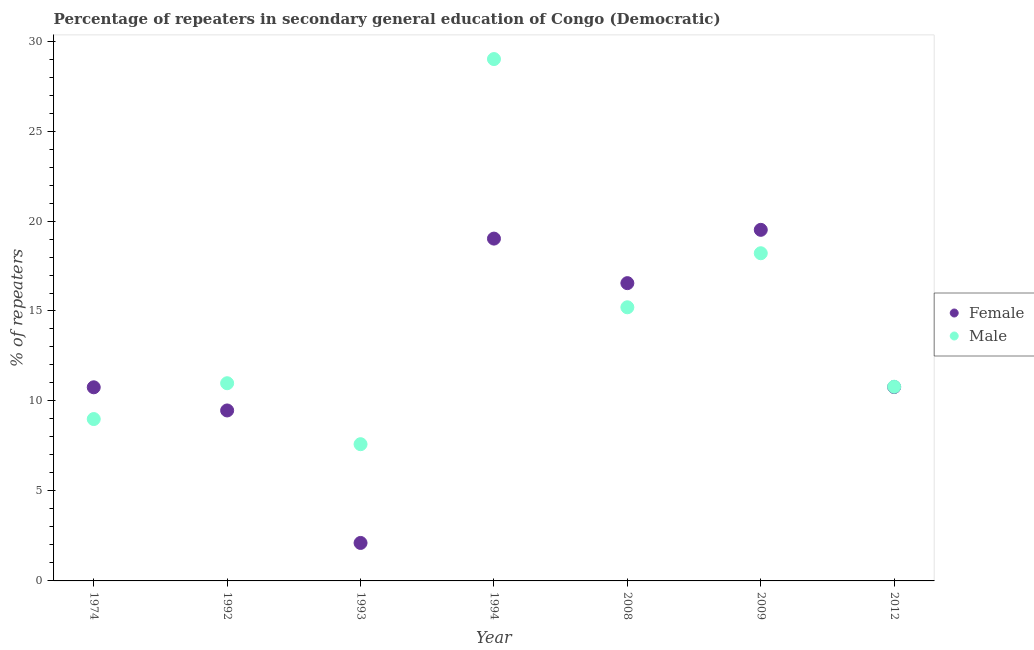What is the percentage of male repeaters in 1994?
Make the answer very short. 29. Across all years, what is the maximum percentage of female repeaters?
Give a very brief answer. 19.51. Across all years, what is the minimum percentage of male repeaters?
Provide a succinct answer. 7.6. In which year was the percentage of female repeaters minimum?
Offer a very short reply. 1993. What is the total percentage of female repeaters in the graph?
Offer a terse response. 88.2. What is the difference between the percentage of male repeaters in 1974 and that in 2008?
Provide a succinct answer. -6.21. What is the difference between the percentage of male repeaters in 1994 and the percentage of female repeaters in 1992?
Provide a short and direct response. 19.53. What is the average percentage of female repeaters per year?
Your response must be concise. 12.6. In the year 1974, what is the difference between the percentage of female repeaters and percentage of male repeaters?
Ensure brevity in your answer.  1.77. What is the ratio of the percentage of male repeaters in 1974 to that in 1992?
Give a very brief answer. 0.82. Is the percentage of female repeaters in 1974 less than that in 1992?
Offer a very short reply. No. What is the difference between the highest and the second highest percentage of male repeaters?
Give a very brief answer. 10.79. What is the difference between the highest and the lowest percentage of male repeaters?
Keep it short and to the point. 21.4. Is the sum of the percentage of female repeaters in 2009 and 2012 greater than the maximum percentage of male repeaters across all years?
Your answer should be compact. Yes. Does the percentage of male repeaters monotonically increase over the years?
Your answer should be very brief. No. Is the percentage of female repeaters strictly greater than the percentage of male repeaters over the years?
Ensure brevity in your answer.  No. Is the percentage of male repeaters strictly less than the percentage of female repeaters over the years?
Your answer should be very brief. No. How many years are there in the graph?
Your answer should be compact. 7. What is the difference between two consecutive major ticks on the Y-axis?
Your answer should be very brief. 5. Where does the legend appear in the graph?
Keep it short and to the point. Center right. What is the title of the graph?
Keep it short and to the point. Percentage of repeaters in secondary general education of Congo (Democratic). Does "Primary completion rate" appear as one of the legend labels in the graph?
Make the answer very short. No. What is the label or title of the Y-axis?
Provide a succinct answer. % of repeaters. What is the % of repeaters of Female in 1974?
Your answer should be compact. 10.76. What is the % of repeaters of Male in 1974?
Make the answer very short. 8.99. What is the % of repeaters of Female in 1992?
Ensure brevity in your answer.  9.47. What is the % of repeaters in Male in 1992?
Keep it short and to the point. 10.99. What is the % of repeaters in Female in 1993?
Your answer should be very brief. 2.11. What is the % of repeaters in Male in 1993?
Keep it short and to the point. 7.6. What is the % of repeaters of Female in 1994?
Offer a very short reply. 19.02. What is the % of repeaters in Male in 1994?
Keep it short and to the point. 29. What is the % of repeaters of Female in 2008?
Keep it short and to the point. 16.55. What is the % of repeaters in Male in 2008?
Offer a terse response. 15.21. What is the % of repeaters in Female in 2009?
Give a very brief answer. 19.51. What is the % of repeaters in Male in 2009?
Give a very brief answer. 18.21. What is the % of repeaters in Female in 2012?
Your answer should be very brief. 10.77. What is the % of repeaters of Male in 2012?
Provide a short and direct response. 10.79. Across all years, what is the maximum % of repeaters of Female?
Your response must be concise. 19.51. Across all years, what is the maximum % of repeaters in Male?
Provide a succinct answer. 29. Across all years, what is the minimum % of repeaters in Female?
Keep it short and to the point. 2.11. Across all years, what is the minimum % of repeaters of Male?
Your response must be concise. 7.6. What is the total % of repeaters in Female in the graph?
Offer a terse response. 88.2. What is the total % of repeaters in Male in the graph?
Your response must be concise. 100.79. What is the difference between the % of repeaters in Female in 1974 and that in 1992?
Your answer should be compact. 1.29. What is the difference between the % of repeaters of Male in 1974 and that in 1992?
Your answer should be very brief. -1.99. What is the difference between the % of repeaters of Female in 1974 and that in 1993?
Provide a succinct answer. 8.65. What is the difference between the % of repeaters of Male in 1974 and that in 1993?
Your answer should be very brief. 1.4. What is the difference between the % of repeaters of Female in 1974 and that in 1994?
Keep it short and to the point. -8.26. What is the difference between the % of repeaters in Male in 1974 and that in 1994?
Your response must be concise. -20.01. What is the difference between the % of repeaters in Female in 1974 and that in 2008?
Your response must be concise. -5.79. What is the difference between the % of repeaters in Male in 1974 and that in 2008?
Offer a very short reply. -6.21. What is the difference between the % of repeaters in Female in 1974 and that in 2009?
Your response must be concise. -8.75. What is the difference between the % of repeaters in Male in 1974 and that in 2009?
Offer a very short reply. -9.21. What is the difference between the % of repeaters of Female in 1974 and that in 2012?
Ensure brevity in your answer.  -0.01. What is the difference between the % of repeaters of Male in 1974 and that in 2012?
Give a very brief answer. -1.8. What is the difference between the % of repeaters of Female in 1992 and that in 1993?
Provide a short and direct response. 7.36. What is the difference between the % of repeaters of Male in 1992 and that in 1993?
Your response must be concise. 3.39. What is the difference between the % of repeaters of Female in 1992 and that in 1994?
Give a very brief answer. -9.55. What is the difference between the % of repeaters of Male in 1992 and that in 1994?
Ensure brevity in your answer.  -18.01. What is the difference between the % of repeaters in Female in 1992 and that in 2008?
Provide a succinct answer. -7.08. What is the difference between the % of repeaters of Male in 1992 and that in 2008?
Give a very brief answer. -4.22. What is the difference between the % of repeaters in Female in 1992 and that in 2009?
Your answer should be compact. -10.04. What is the difference between the % of repeaters in Male in 1992 and that in 2009?
Ensure brevity in your answer.  -7.22. What is the difference between the % of repeaters in Female in 1992 and that in 2012?
Your response must be concise. -1.3. What is the difference between the % of repeaters of Male in 1992 and that in 2012?
Keep it short and to the point. 0.19. What is the difference between the % of repeaters of Female in 1993 and that in 1994?
Make the answer very short. -16.91. What is the difference between the % of repeaters of Male in 1993 and that in 1994?
Your response must be concise. -21.4. What is the difference between the % of repeaters in Female in 1993 and that in 2008?
Ensure brevity in your answer.  -14.44. What is the difference between the % of repeaters of Male in 1993 and that in 2008?
Your answer should be very brief. -7.61. What is the difference between the % of repeaters in Female in 1993 and that in 2009?
Your answer should be compact. -17.4. What is the difference between the % of repeaters in Male in 1993 and that in 2009?
Give a very brief answer. -10.61. What is the difference between the % of repeaters of Female in 1993 and that in 2012?
Make the answer very short. -8.66. What is the difference between the % of repeaters of Male in 1993 and that in 2012?
Offer a very short reply. -3.19. What is the difference between the % of repeaters in Female in 1994 and that in 2008?
Make the answer very short. 2.48. What is the difference between the % of repeaters in Male in 1994 and that in 2008?
Keep it short and to the point. 13.79. What is the difference between the % of repeaters of Female in 1994 and that in 2009?
Make the answer very short. -0.49. What is the difference between the % of repeaters in Male in 1994 and that in 2009?
Offer a very short reply. 10.79. What is the difference between the % of repeaters of Female in 1994 and that in 2012?
Ensure brevity in your answer.  8.25. What is the difference between the % of repeaters in Male in 1994 and that in 2012?
Your answer should be compact. 18.21. What is the difference between the % of repeaters of Female in 2008 and that in 2009?
Make the answer very short. -2.96. What is the difference between the % of repeaters of Male in 2008 and that in 2009?
Keep it short and to the point. -3. What is the difference between the % of repeaters of Female in 2008 and that in 2012?
Your answer should be compact. 5.77. What is the difference between the % of repeaters in Male in 2008 and that in 2012?
Provide a short and direct response. 4.41. What is the difference between the % of repeaters of Female in 2009 and that in 2012?
Provide a short and direct response. 8.74. What is the difference between the % of repeaters in Male in 2009 and that in 2012?
Offer a very short reply. 7.42. What is the difference between the % of repeaters of Female in 1974 and the % of repeaters of Male in 1992?
Make the answer very short. -0.23. What is the difference between the % of repeaters in Female in 1974 and the % of repeaters in Male in 1993?
Make the answer very short. 3.16. What is the difference between the % of repeaters in Female in 1974 and the % of repeaters in Male in 1994?
Make the answer very short. -18.24. What is the difference between the % of repeaters in Female in 1974 and the % of repeaters in Male in 2008?
Your answer should be very brief. -4.45. What is the difference between the % of repeaters of Female in 1974 and the % of repeaters of Male in 2009?
Offer a very short reply. -7.45. What is the difference between the % of repeaters of Female in 1974 and the % of repeaters of Male in 2012?
Keep it short and to the point. -0.03. What is the difference between the % of repeaters in Female in 1992 and the % of repeaters in Male in 1993?
Offer a very short reply. 1.87. What is the difference between the % of repeaters in Female in 1992 and the % of repeaters in Male in 1994?
Provide a succinct answer. -19.53. What is the difference between the % of repeaters of Female in 1992 and the % of repeaters of Male in 2008?
Keep it short and to the point. -5.73. What is the difference between the % of repeaters of Female in 1992 and the % of repeaters of Male in 2009?
Provide a succinct answer. -8.74. What is the difference between the % of repeaters in Female in 1992 and the % of repeaters in Male in 2012?
Your answer should be very brief. -1.32. What is the difference between the % of repeaters of Female in 1993 and the % of repeaters of Male in 1994?
Provide a short and direct response. -26.89. What is the difference between the % of repeaters of Female in 1993 and the % of repeaters of Male in 2008?
Make the answer very short. -13.1. What is the difference between the % of repeaters in Female in 1993 and the % of repeaters in Male in 2009?
Provide a succinct answer. -16.1. What is the difference between the % of repeaters of Female in 1993 and the % of repeaters of Male in 2012?
Give a very brief answer. -8.68. What is the difference between the % of repeaters of Female in 1994 and the % of repeaters of Male in 2008?
Your answer should be very brief. 3.82. What is the difference between the % of repeaters in Female in 1994 and the % of repeaters in Male in 2009?
Your response must be concise. 0.81. What is the difference between the % of repeaters of Female in 1994 and the % of repeaters of Male in 2012?
Offer a terse response. 8.23. What is the difference between the % of repeaters of Female in 2008 and the % of repeaters of Male in 2009?
Make the answer very short. -1.66. What is the difference between the % of repeaters in Female in 2008 and the % of repeaters in Male in 2012?
Provide a short and direct response. 5.76. What is the difference between the % of repeaters of Female in 2009 and the % of repeaters of Male in 2012?
Give a very brief answer. 8.72. What is the average % of repeaters of Female per year?
Your answer should be compact. 12.6. What is the average % of repeaters of Male per year?
Your answer should be compact. 14.4. In the year 1974, what is the difference between the % of repeaters in Female and % of repeaters in Male?
Your answer should be very brief. 1.77. In the year 1992, what is the difference between the % of repeaters in Female and % of repeaters in Male?
Your response must be concise. -1.51. In the year 1993, what is the difference between the % of repeaters of Female and % of repeaters of Male?
Make the answer very short. -5.49. In the year 1994, what is the difference between the % of repeaters in Female and % of repeaters in Male?
Provide a short and direct response. -9.98. In the year 2008, what is the difference between the % of repeaters of Female and % of repeaters of Male?
Your response must be concise. 1.34. In the year 2009, what is the difference between the % of repeaters of Female and % of repeaters of Male?
Your response must be concise. 1.3. In the year 2012, what is the difference between the % of repeaters in Female and % of repeaters in Male?
Make the answer very short. -0.02. What is the ratio of the % of repeaters of Female in 1974 to that in 1992?
Ensure brevity in your answer.  1.14. What is the ratio of the % of repeaters of Male in 1974 to that in 1992?
Make the answer very short. 0.82. What is the ratio of the % of repeaters of Female in 1974 to that in 1993?
Offer a terse response. 5.1. What is the ratio of the % of repeaters in Male in 1974 to that in 1993?
Offer a terse response. 1.18. What is the ratio of the % of repeaters in Female in 1974 to that in 1994?
Provide a succinct answer. 0.57. What is the ratio of the % of repeaters in Male in 1974 to that in 1994?
Your answer should be compact. 0.31. What is the ratio of the % of repeaters of Female in 1974 to that in 2008?
Give a very brief answer. 0.65. What is the ratio of the % of repeaters of Male in 1974 to that in 2008?
Your answer should be very brief. 0.59. What is the ratio of the % of repeaters in Female in 1974 to that in 2009?
Your answer should be compact. 0.55. What is the ratio of the % of repeaters of Male in 1974 to that in 2009?
Offer a very short reply. 0.49. What is the ratio of the % of repeaters of Male in 1974 to that in 2012?
Ensure brevity in your answer.  0.83. What is the ratio of the % of repeaters in Female in 1992 to that in 1993?
Provide a short and direct response. 4.49. What is the ratio of the % of repeaters in Male in 1992 to that in 1993?
Your answer should be very brief. 1.45. What is the ratio of the % of repeaters of Female in 1992 to that in 1994?
Offer a very short reply. 0.5. What is the ratio of the % of repeaters in Male in 1992 to that in 1994?
Ensure brevity in your answer.  0.38. What is the ratio of the % of repeaters in Female in 1992 to that in 2008?
Your response must be concise. 0.57. What is the ratio of the % of repeaters of Male in 1992 to that in 2008?
Make the answer very short. 0.72. What is the ratio of the % of repeaters of Female in 1992 to that in 2009?
Your response must be concise. 0.49. What is the ratio of the % of repeaters of Male in 1992 to that in 2009?
Give a very brief answer. 0.6. What is the ratio of the % of repeaters in Female in 1992 to that in 2012?
Provide a succinct answer. 0.88. What is the ratio of the % of repeaters in Female in 1993 to that in 1994?
Your answer should be compact. 0.11. What is the ratio of the % of repeaters in Male in 1993 to that in 1994?
Offer a very short reply. 0.26. What is the ratio of the % of repeaters of Female in 1993 to that in 2008?
Your response must be concise. 0.13. What is the ratio of the % of repeaters of Male in 1993 to that in 2008?
Keep it short and to the point. 0.5. What is the ratio of the % of repeaters of Female in 1993 to that in 2009?
Your answer should be compact. 0.11. What is the ratio of the % of repeaters in Male in 1993 to that in 2009?
Your answer should be very brief. 0.42. What is the ratio of the % of repeaters of Female in 1993 to that in 2012?
Give a very brief answer. 0.2. What is the ratio of the % of repeaters in Male in 1993 to that in 2012?
Give a very brief answer. 0.7. What is the ratio of the % of repeaters in Female in 1994 to that in 2008?
Your answer should be compact. 1.15. What is the ratio of the % of repeaters in Male in 1994 to that in 2008?
Ensure brevity in your answer.  1.91. What is the ratio of the % of repeaters of Male in 1994 to that in 2009?
Offer a very short reply. 1.59. What is the ratio of the % of repeaters of Female in 1994 to that in 2012?
Provide a succinct answer. 1.77. What is the ratio of the % of repeaters of Male in 1994 to that in 2012?
Give a very brief answer. 2.69. What is the ratio of the % of repeaters in Female in 2008 to that in 2009?
Your answer should be compact. 0.85. What is the ratio of the % of repeaters of Male in 2008 to that in 2009?
Provide a short and direct response. 0.84. What is the ratio of the % of repeaters of Female in 2008 to that in 2012?
Your answer should be very brief. 1.54. What is the ratio of the % of repeaters of Male in 2008 to that in 2012?
Your answer should be very brief. 1.41. What is the ratio of the % of repeaters of Female in 2009 to that in 2012?
Your answer should be very brief. 1.81. What is the ratio of the % of repeaters of Male in 2009 to that in 2012?
Ensure brevity in your answer.  1.69. What is the difference between the highest and the second highest % of repeaters of Female?
Keep it short and to the point. 0.49. What is the difference between the highest and the second highest % of repeaters in Male?
Your answer should be compact. 10.79. What is the difference between the highest and the lowest % of repeaters in Female?
Your response must be concise. 17.4. What is the difference between the highest and the lowest % of repeaters in Male?
Provide a succinct answer. 21.4. 